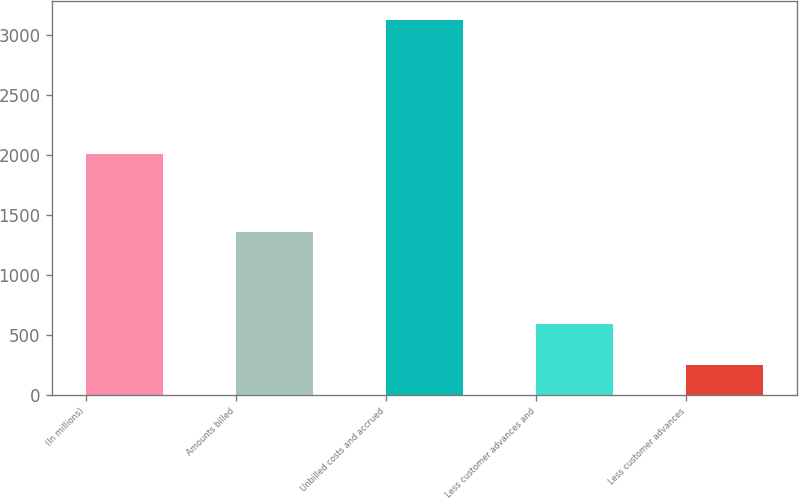Convert chart to OTSL. <chart><loc_0><loc_0><loc_500><loc_500><bar_chart><fcel>(In millions)<fcel>Amounts billed<fcel>Unbilled costs and accrued<fcel>Less customer advances and<fcel>Less customer advances<nl><fcel>2010<fcel>1360<fcel>3127<fcel>591<fcel>249<nl></chart> 